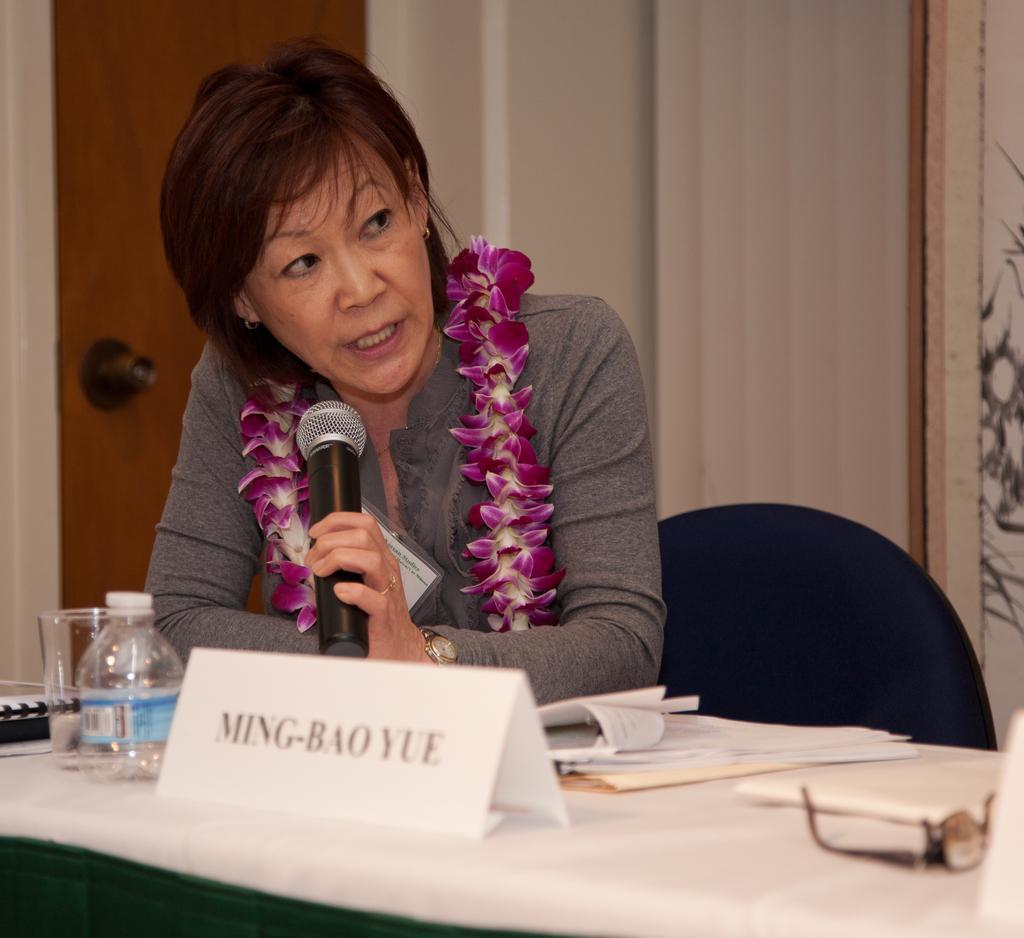In one or two sentences, can you explain what this image depicts? She is sitting on a chair. She is holding a mic. There is a table. There is a name board ,bottle,glass,keyboard and name board on a table. 